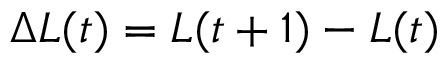Convert formula to latex. <formula><loc_0><loc_0><loc_500><loc_500>\Delta L ( t ) = L ( t + 1 ) - L ( t )</formula> 